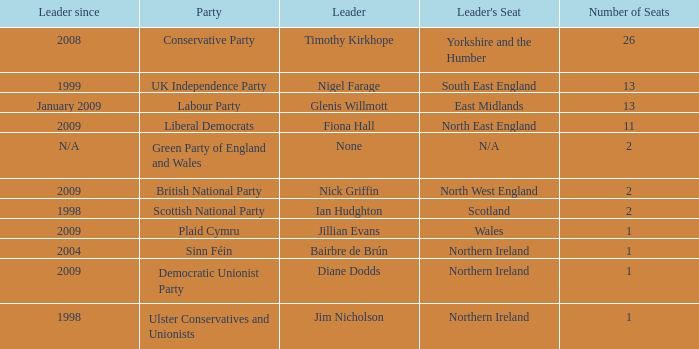What is Jillian Evans highest number of seats? 1.0. 